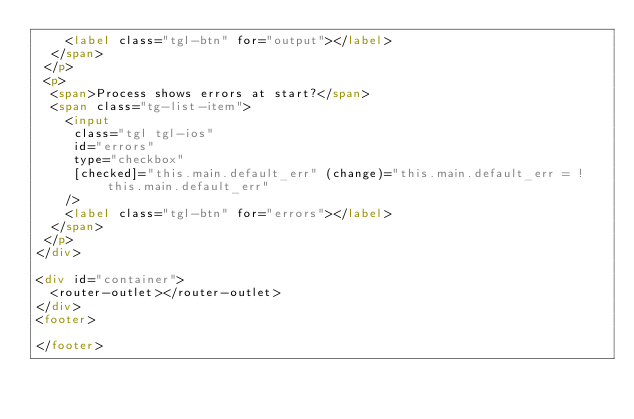<code> <loc_0><loc_0><loc_500><loc_500><_HTML_>    <label class="tgl-btn" for="output"></label>
  </span>
 </p>
 <p>
  <span>Process shows errors at start?</span>
  <span class="tg-list-item">
    <input
     class="tgl tgl-ios"
     id="errors"
     type="checkbox"
     [checked]="this.main.default_err" (change)="this.main.default_err = !this.main.default_err"
    />
    <label class="tgl-btn" for="errors"></label>
  </span>
 </p>
</div>

<div id="container">
  <router-outlet></router-outlet>
</div>
<footer>

</footer>
</code> 